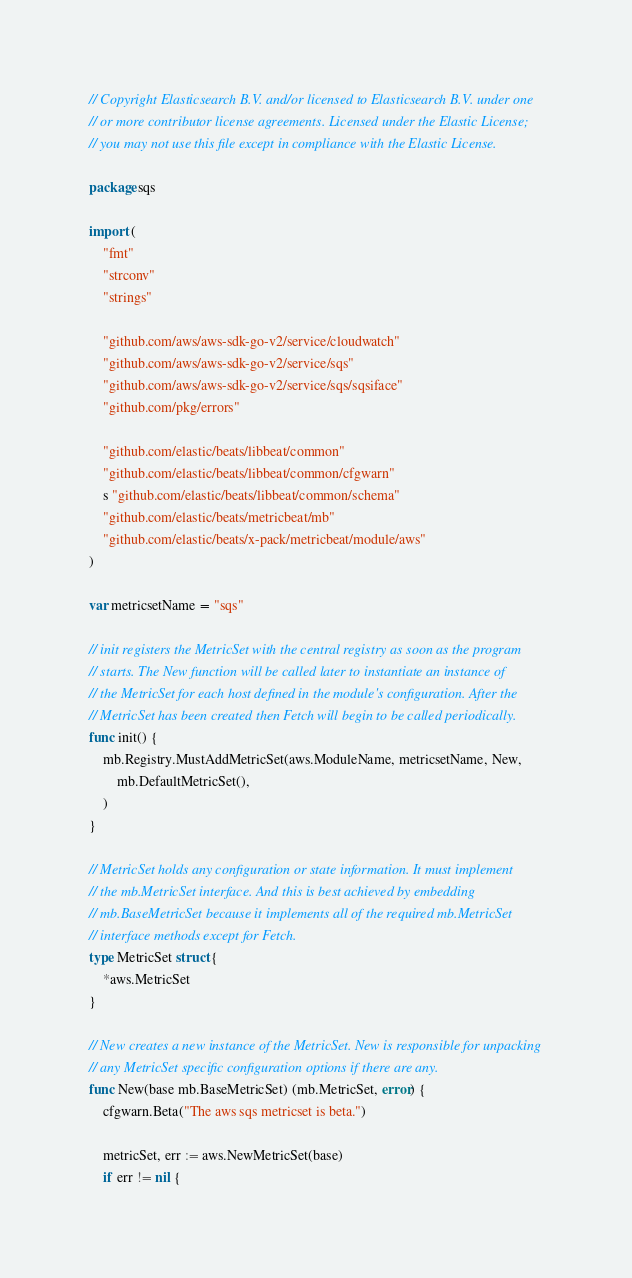Convert code to text. <code><loc_0><loc_0><loc_500><loc_500><_Go_>// Copyright Elasticsearch B.V. and/or licensed to Elasticsearch B.V. under one
// or more contributor license agreements. Licensed under the Elastic License;
// you may not use this file except in compliance with the Elastic License.

package sqs

import (
	"fmt"
	"strconv"
	"strings"

	"github.com/aws/aws-sdk-go-v2/service/cloudwatch"
	"github.com/aws/aws-sdk-go-v2/service/sqs"
	"github.com/aws/aws-sdk-go-v2/service/sqs/sqsiface"
	"github.com/pkg/errors"

	"github.com/elastic/beats/libbeat/common"
	"github.com/elastic/beats/libbeat/common/cfgwarn"
	s "github.com/elastic/beats/libbeat/common/schema"
	"github.com/elastic/beats/metricbeat/mb"
	"github.com/elastic/beats/x-pack/metricbeat/module/aws"
)

var metricsetName = "sqs"

// init registers the MetricSet with the central registry as soon as the program
// starts. The New function will be called later to instantiate an instance of
// the MetricSet for each host defined in the module's configuration. After the
// MetricSet has been created then Fetch will begin to be called periodically.
func init() {
	mb.Registry.MustAddMetricSet(aws.ModuleName, metricsetName, New,
		mb.DefaultMetricSet(),
	)
}

// MetricSet holds any configuration or state information. It must implement
// the mb.MetricSet interface. And this is best achieved by embedding
// mb.BaseMetricSet because it implements all of the required mb.MetricSet
// interface methods except for Fetch.
type MetricSet struct {
	*aws.MetricSet
}

// New creates a new instance of the MetricSet. New is responsible for unpacking
// any MetricSet specific configuration options if there are any.
func New(base mb.BaseMetricSet) (mb.MetricSet, error) {
	cfgwarn.Beta("The aws sqs metricset is beta.")

	metricSet, err := aws.NewMetricSet(base)
	if err != nil {</code> 